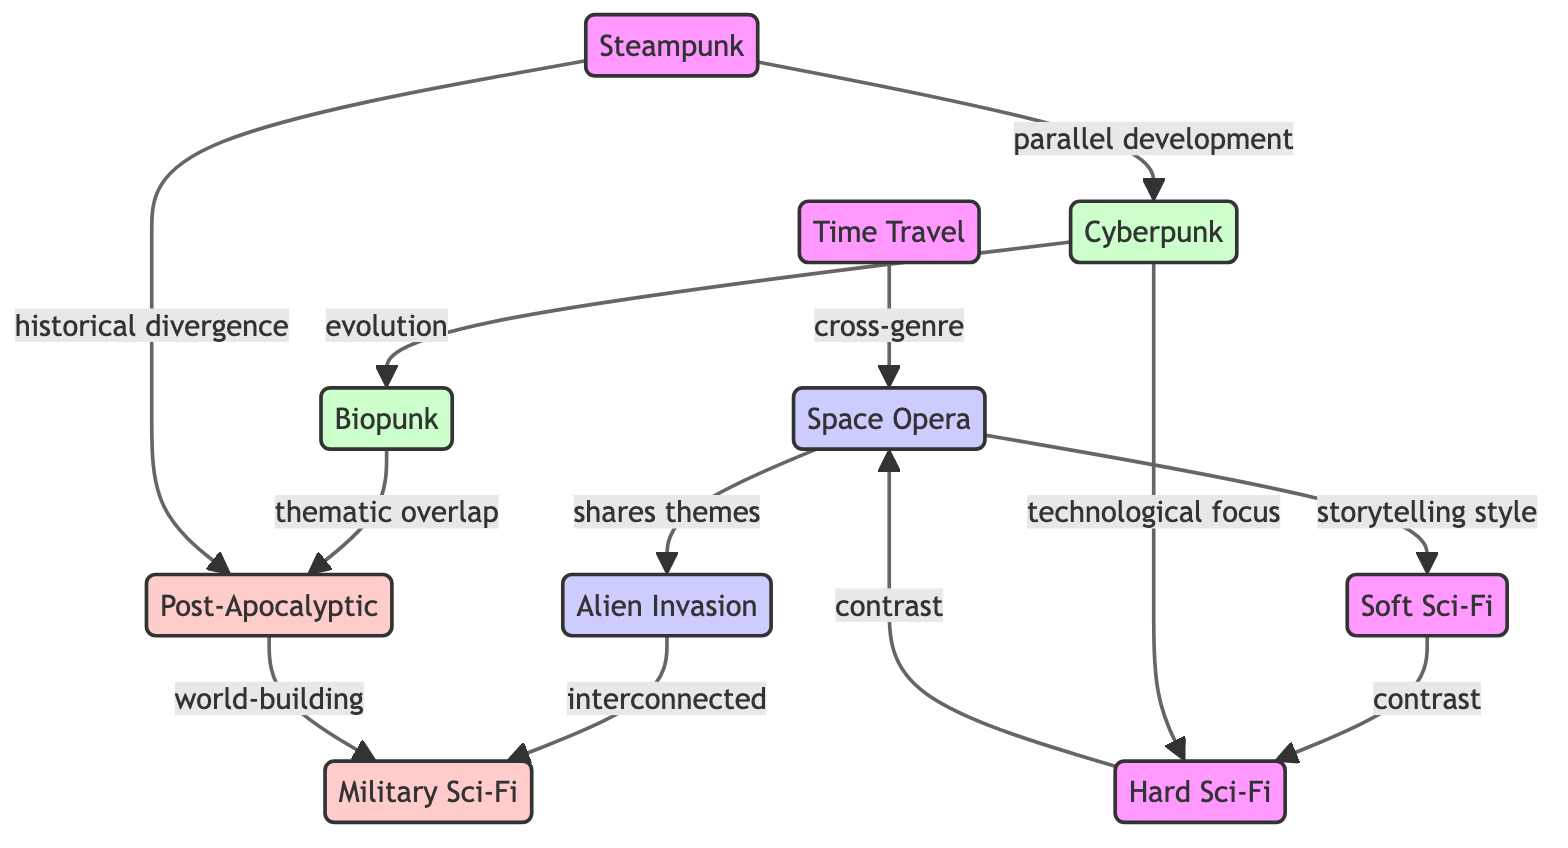What is the total number of nodes in the diagram? The diagram lists 10 different subgenres of sci-fi, each represented as a node within the network. By counting each unique node, we find that there are 10 nodes in total.
Answer: 10 Which subgenre shares themes with Alien Invasion? In the diagram, the edge labeled "shares themes" connects Space Opera to Alien Invasion, indicating that Space Opera is the subgenre that has themes in common with Alien Invasion.
Answer: Space Opera What type of relationship exists between Cyberpunk and Biopunk? The relationship between Cyberpunk and Biopunk is labeled "evolution" in the diagram, indicating that Biopunk is considered to have evolved from Cyberpunk.
Answer: evolution How many edges are there in total? The diagram indicates various relationships between the 10 nodes, and by counting each line connecting nodes, we find there are 11 edges within the network.
Answer: 11 Which two subgenres have a contrast relationship? The diagram shows several contrasts, but two specific subgenres that have a direct contrast relationship are Hard Sci-Fi and Space Opera, indicated by the edge labeled "contrast."
Answer: Hard Sci-Fi, Space Opera What relationship does Military Sci-Fi have with Alien Invasion? The diagram shows an edge labeled "interconnected" that directly connects Alien Invasion to Military Sci-Fi, indicating that these two subgenres share some connection or relevance.
Answer: interconnected Which two subgenres are related through world-building? The "world-building" relationship in the diagram connects Post-Apocalyptic to Military Sci-Fi, suggesting that they are relevant to each other's world-building themes.
Answer: Post-Apocalyptic, Military Sci-Fi How does Steampunk relate to Cyberpunk? Steampunk is noted in the diagram as having a "parallel development" with Cyberpunk, showing that they developed alongside each other despite differing themes or styles.
Answer: parallel development Which subgenre is characterized by a technological focus? The relationship labeled "technological focus" connects Cyberpunk to Hard Sci-Fi, indicating that Cyberpunk is specifically known for its emphasis on technological aspects.
Answer: Cyberpunk 